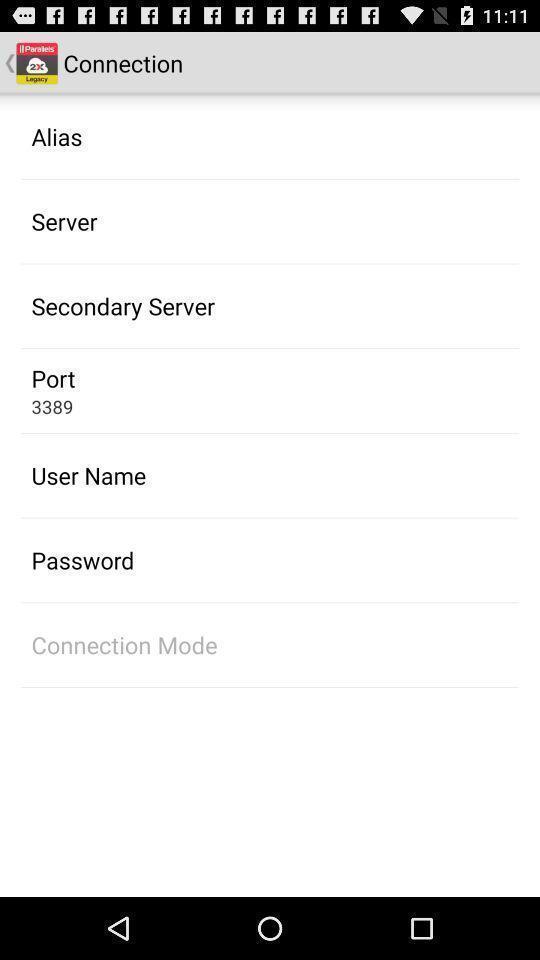What details can you identify in this image? List of options in the connection page. 